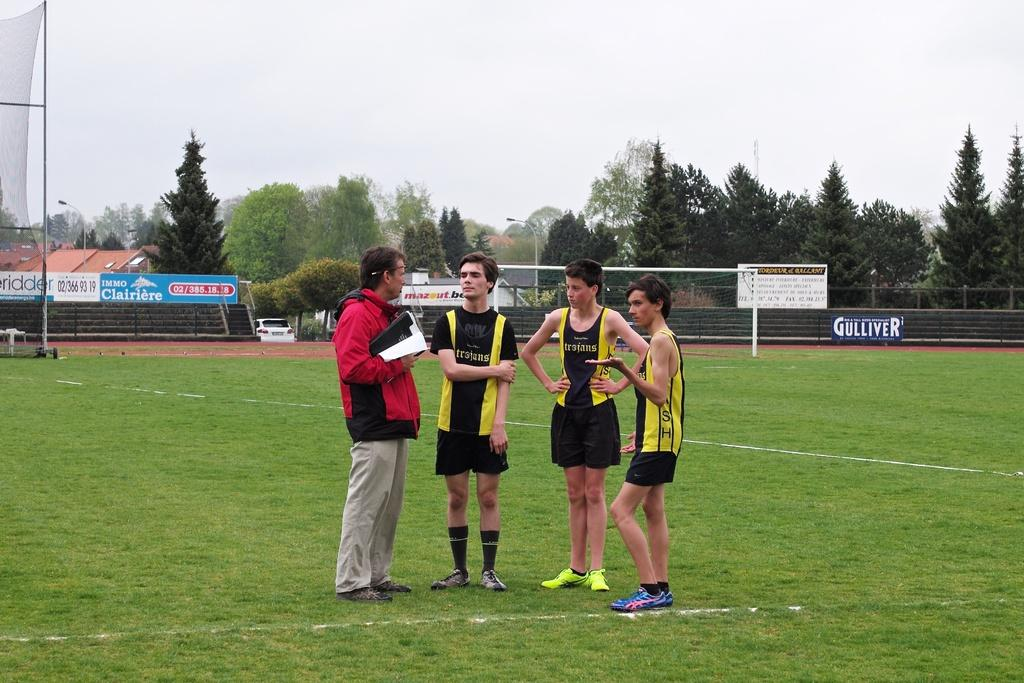<image>
Create a compact narrative representing the image presented. Gulliver has a big blue banner along the fence. 